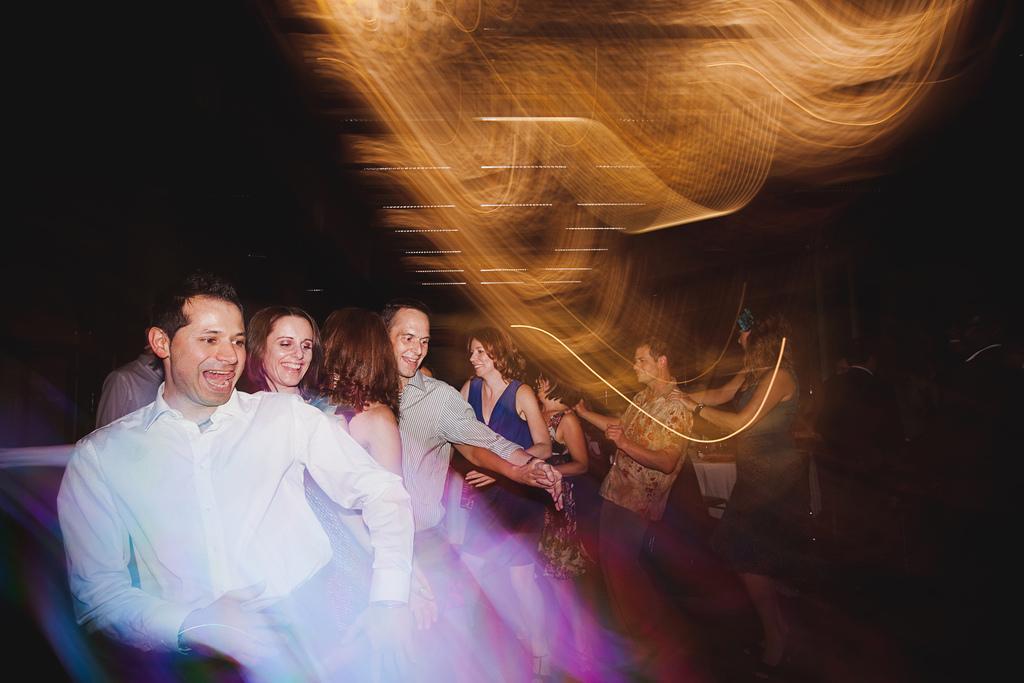Can you describe this image briefly? In this image we can see few people dancing and a dark background. 